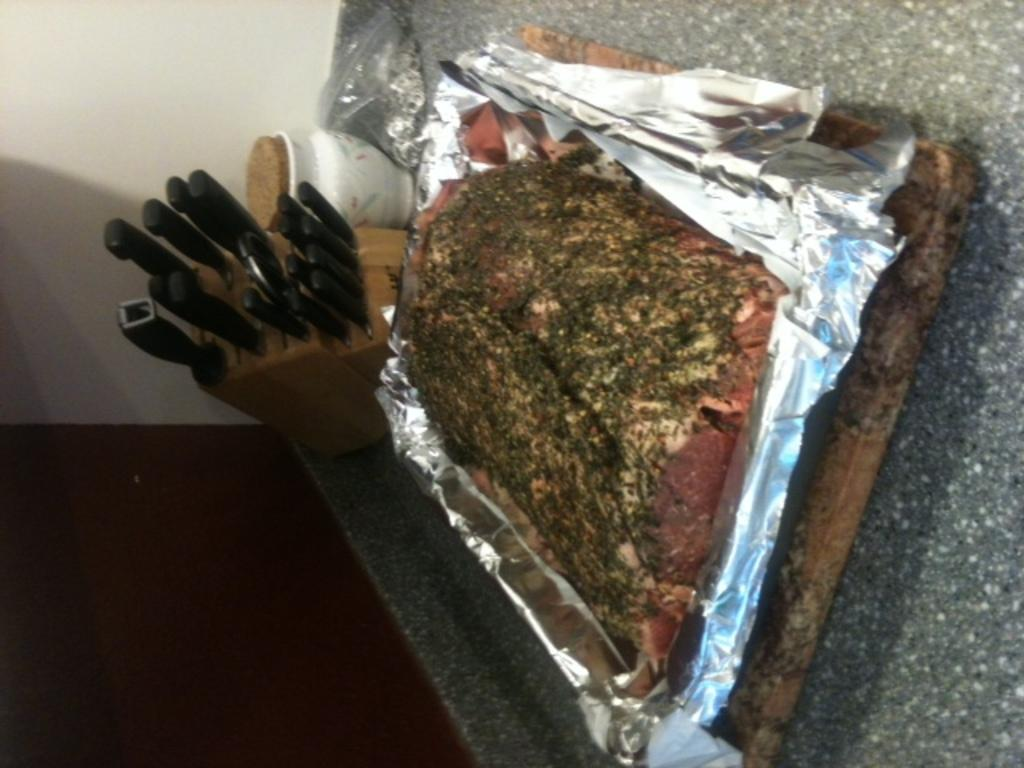What is the main subject in the center of the image? There is meat on a tray in the center of the image. What objects can be seen in the background of the image? There are knives and a jar in the background of the image. What type of furniture is present at the bottom of the image? There is a table at the bottom of the image. How many giants are visible in the image? There are no giants present in the image. What type of wheel is used to prepare the meat in the image? There is no wheel present in the image, nor is there any indication of meat preparation. 